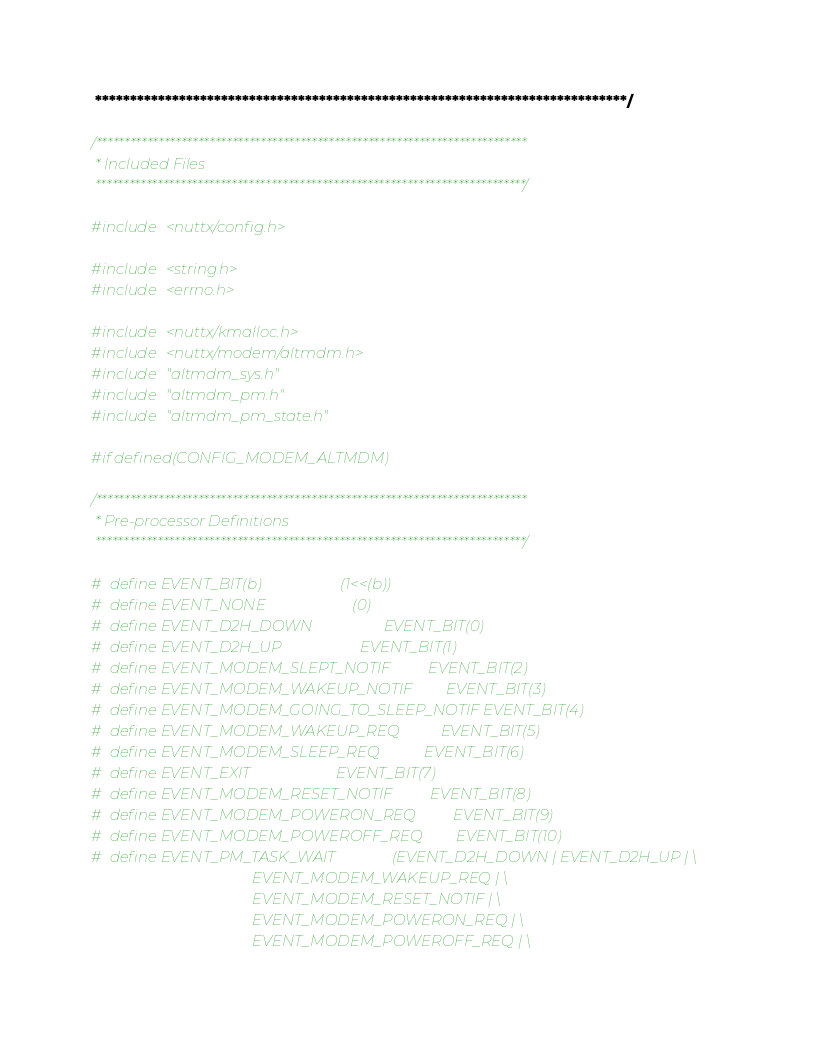Convert code to text. <code><loc_0><loc_0><loc_500><loc_500><_C_> ****************************************************************************/

/****************************************************************************
 * Included Files
 ****************************************************************************/

#include <nuttx/config.h>

#include <string.h>
#include <errno.h>

#include <nuttx/kmalloc.h>
#include <nuttx/modem/altmdm.h>
#include "altmdm_sys.h"
#include "altmdm_pm.h"
#include "altmdm_pm_state.h"

#if defined(CONFIG_MODEM_ALTMDM)

/****************************************************************************
 * Pre-processor Definitions
 ****************************************************************************/

#  define EVENT_BIT(b)                     (1<<(b))
#  define EVENT_NONE                       (0)
#  define EVENT_D2H_DOWN                   EVENT_BIT(0)
#  define EVENT_D2H_UP                     EVENT_BIT(1)
#  define EVENT_MODEM_SLEPT_NOTIF          EVENT_BIT(2)
#  define EVENT_MODEM_WAKEUP_NOTIF         EVENT_BIT(3)
#  define EVENT_MODEM_GOING_TO_SLEEP_NOTIF EVENT_BIT(4)
#  define EVENT_MODEM_WAKEUP_REQ           EVENT_BIT(5)
#  define EVENT_MODEM_SLEEP_REQ            EVENT_BIT(6)
#  define EVENT_EXIT                       EVENT_BIT(7)
#  define EVENT_MODEM_RESET_NOTIF          EVENT_BIT(8)
#  define EVENT_MODEM_POWERON_REQ          EVENT_BIT(9)
#  define EVENT_MODEM_POWEROFF_REQ         EVENT_BIT(10)
#  define EVENT_PM_TASK_WAIT               (EVENT_D2H_DOWN | EVENT_D2H_UP | \
                                           EVENT_MODEM_WAKEUP_REQ | \
                                           EVENT_MODEM_RESET_NOTIF | \
                                           EVENT_MODEM_POWERON_REQ | \
                                           EVENT_MODEM_POWEROFF_REQ | \</code> 